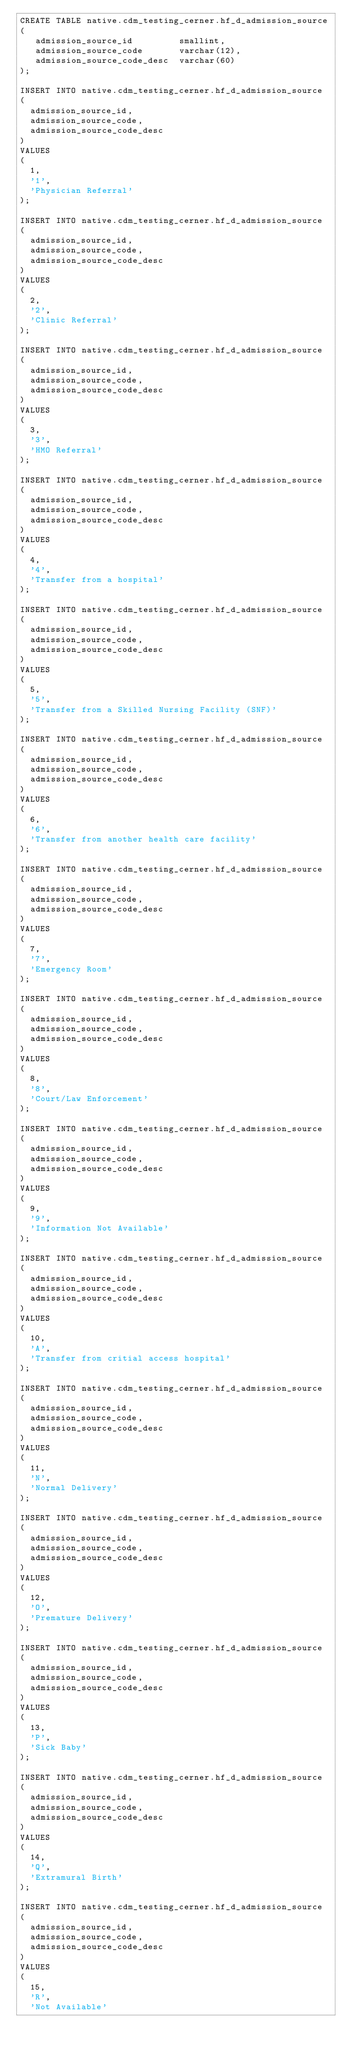<code> <loc_0><loc_0><loc_500><loc_500><_SQL_>CREATE TABLE native.cdm_testing_cerner.hf_d_admission_source
(
   admission_source_id         smallint,
   admission_source_code       varchar(12),
   admission_source_code_desc  varchar(60)
);

INSERT INTO native.cdm_testing_cerner.hf_d_admission_source
(
  admission_source_id,
  admission_source_code,
  admission_source_code_desc
)
VALUES
(
  1,
  '1',
  'Physician Referral'
);

INSERT INTO native.cdm_testing_cerner.hf_d_admission_source
(
  admission_source_id,
  admission_source_code,
  admission_source_code_desc
)
VALUES
(
  2,
  '2',
  'Clinic Referral'
);

INSERT INTO native.cdm_testing_cerner.hf_d_admission_source
(
  admission_source_id,
  admission_source_code,
  admission_source_code_desc
)
VALUES
(
  3,
  '3',
  'HMO Referral'
);

INSERT INTO native.cdm_testing_cerner.hf_d_admission_source
(
  admission_source_id,
  admission_source_code,
  admission_source_code_desc
)
VALUES
(
  4,
  '4',
  'Transfer from a hospital'
);

INSERT INTO native.cdm_testing_cerner.hf_d_admission_source
(
  admission_source_id,
  admission_source_code,
  admission_source_code_desc
)
VALUES
(
  5,
  '5',
  'Transfer from a Skilled Nursing Facility (SNF)'
);

INSERT INTO native.cdm_testing_cerner.hf_d_admission_source
(
  admission_source_id,
  admission_source_code,
  admission_source_code_desc
)
VALUES
(
  6,
  '6',
  'Transfer from another health care facility'
);

INSERT INTO native.cdm_testing_cerner.hf_d_admission_source
(
  admission_source_id,
  admission_source_code,
  admission_source_code_desc
)
VALUES
(
  7,
  '7',
  'Emergency Room'
);

INSERT INTO native.cdm_testing_cerner.hf_d_admission_source
(
  admission_source_id,
  admission_source_code,
  admission_source_code_desc
)
VALUES
(
  8,
  '8',
  'Court/Law Enforcement'
);

INSERT INTO native.cdm_testing_cerner.hf_d_admission_source
(
  admission_source_id,
  admission_source_code,
  admission_source_code_desc
)
VALUES
(
  9,
  '9',
  'Information Not Available'
);

INSERT INTO native.cdm_testing_cerner.hf_d_admission_source
(
  admission_source_id,
  admission_source_code,
  admission_source_code_desc
)
VALUES
(
  10,
  'A',
  'Transfer from critial access hospital'
);

INSERT INTO native.cdm_testing_cerner.hf_d_admission_source
(
  admission_source_id,
  admission_source_code,
  admission_source_code_desc
)
VALUES
(
  11,
  'N',
  'Normal Delivery'
);

INSERT INTO native.cdm_testing_cerner.hf_d_admission_source
(
  admission_source_id,
  admission_source_code,
  admission_source_code_desc
)
VALUES
(
  12,
  'O',
  'Premature Delivery'
);

INSERT INTO native.cdm_testing_cerner.hf_d_admission_source
(
  admission_source_id,
  admission_source_code,
  admission_source_code_desc
)
VALUES
(
  13,
  'P',
  'Sick Baby'
);

INSERT INTO native.cdm_testing_cerner.hf_d_admission_source
(
  admission_source_id,
  admission_source_code,
  admission_source_code_desc
)
VALUES
(
  14,
  'Q',
  'Extramural Birth'
);

INSERT INTO native.cdm_testing_cerner.hf_d_admission_source
(
  admission_source_id,
  admission_source_code,
  admission_source_code_desc
)
VALUES
(
  15,
  'R',
  'Not Available'</code> 